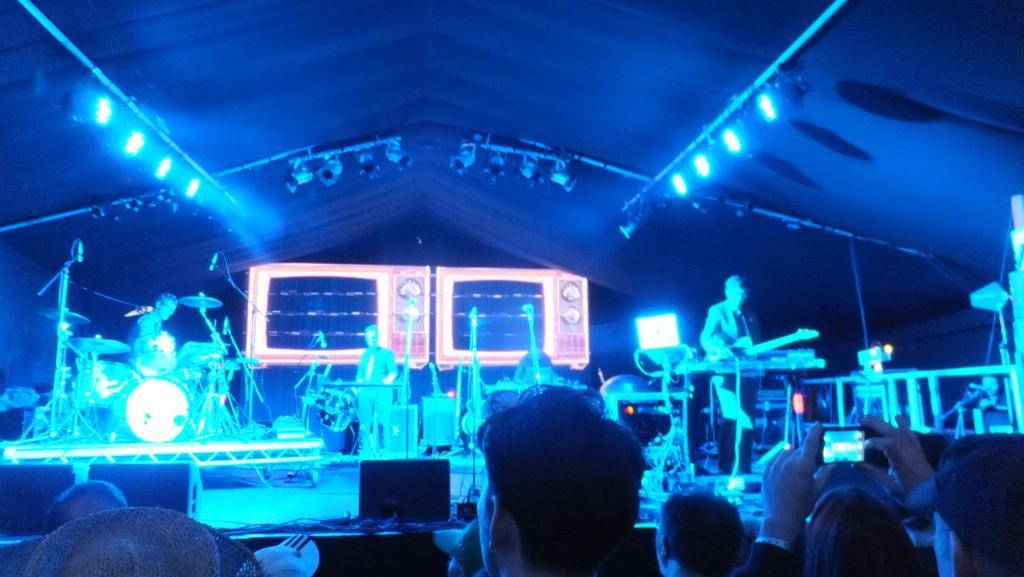How would you summarize this image in a sentence or two? This picture describes about group of people, few people are playing musical instruments on the stage,we can find couple of lights. 